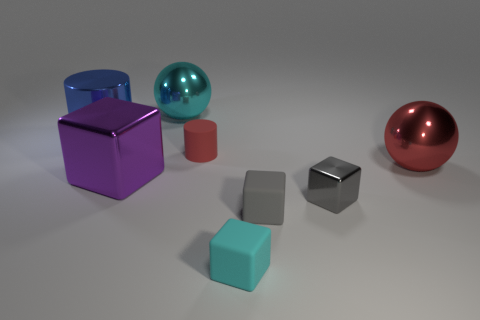Subtract all large purple cubes. How many cubes are left? 3 Subtract all blue cylinders. How many cylinders are left? 1 Subtract all spheres. How many objects are left? 6 Subtract all gray spheres. How many gray blocks are left? 2 Subtract 1 cubes. How many cubes are left? 3 Add 2 tiny blue rubber cylinders. How many tiny blue rubber cylinders exist? 2 Add 1 small gray shiny objects. How many objects exist? 9 Subtract 0 yellow blocks. How many objects are left? 8 Subtract all gray cylinders. Subtract all purple spheres. How many cylinders are left? 2 Subtract all small red rubber cylinders. Subtract all large shiny cylinders. How many objects are left? 6 